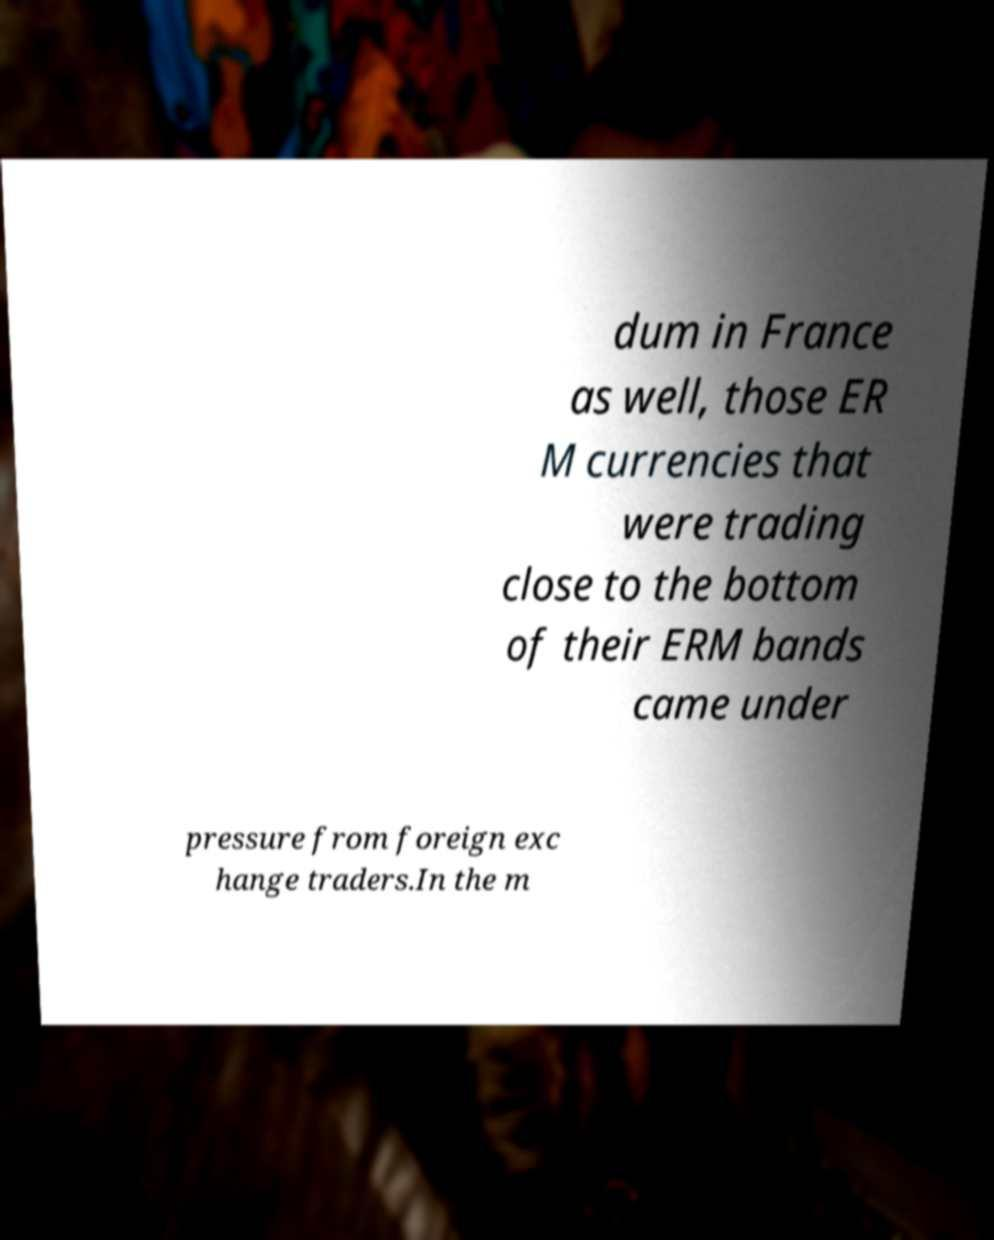Please read and relay the text visible in this image. What does it say? dum in France as well, those ER M currencies that were trading close to the bottom of their ERM bands came under pressure from foreign exc hange traders.In the m 